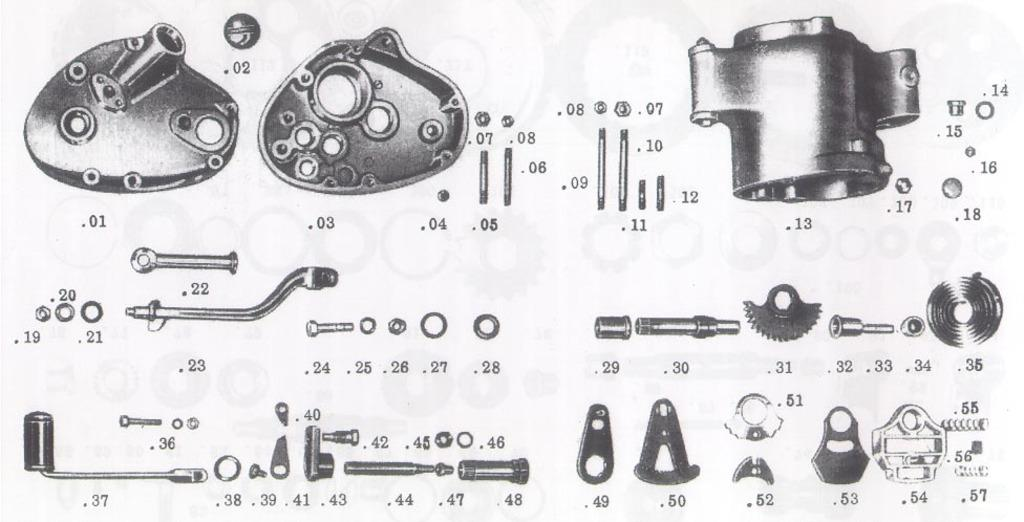What type of objects are present in the image? The image contains mechanical objects. Can you identify any specific details about these objects? There are numbers visible in the image. How many icicles are hanging from the mechanical objects in the image? There are no icicles present in the image; it contains mechanical objects and numbers. What type of star can be seen in the image? There is no star present in the image. 